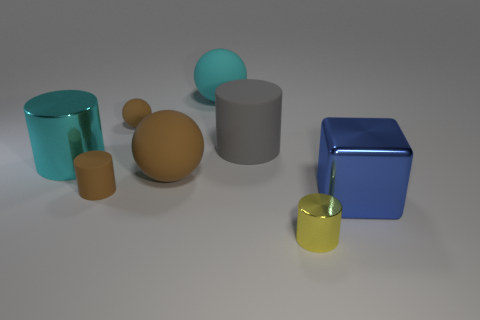Add 1 large gray cylinders. How many objects exist? 9 Subtract all balls. How many objects are left? 5 Add 1 big yellow metal balls. How many big yellow metal balls exist? 1 Subtract 0 yellow spheres. How many objects are left? 8 Subtract all cyan metallic things. Subtract all large metallic blocks. How many objects are left? 6 Add 6 spheres. How many spheres are left? 9 